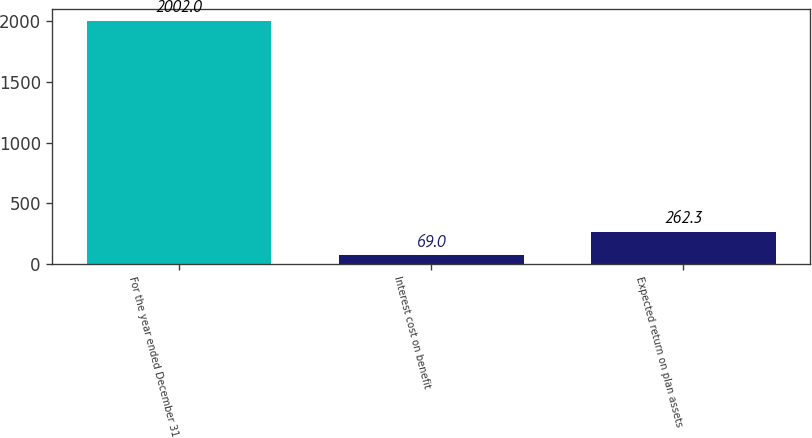<chart> <loc_0><loc_0><loc_500><loc_500><bar_chart><fcel>For the year ended December 31<fcel>Interest cost on benefit<fcel>Expected return on plan assets<nl><fcel>2002<fcel>69<fcel>262.3<nl></chart> 